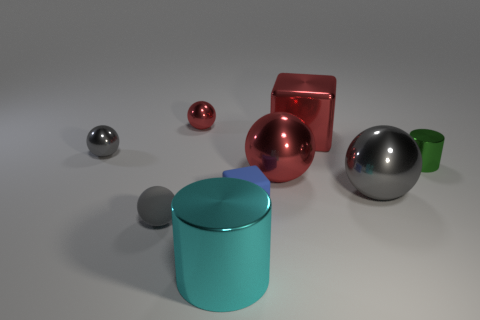Is the number of large red metal objects behind the large cyan metallic object greater than the number of blue matte things in front of the small blue cube?
Your answer should be very brief. Yes. How many cyan objects have the same shape as the tiny red thing?
Offer a very short reply. 0. What number of objects are rubber objects left of the matte cube or tiny shiny things that are to the right of the tiny gray rubber object?
Your answer should be very brief. 3. The small ball behind the tiny metallic ball left of the shiny sphere that is behind the small gray metallic ball is made of what material?
Keep it short and to the point. Metal. Does the shiny sphere that is right of the metallic cube have the same color as the big metallic cube?
Ensure brevity in your answer.  No. The thing that is to the right of the rubber sphere and in front of the small cube is made of what material?
Give a very brief answer. Metal. Are there any green metal objects of the same size as the blue block?
Provide a short and direct response. Yes. What number of metallic things are there?
Offer a very short reply. 7. What number of big red metal balls are right of the small green thing?
Your response must be concise. 0. Is the material of the green thing the same as the large cyan object?
Keep it short and to the point. Yes. 